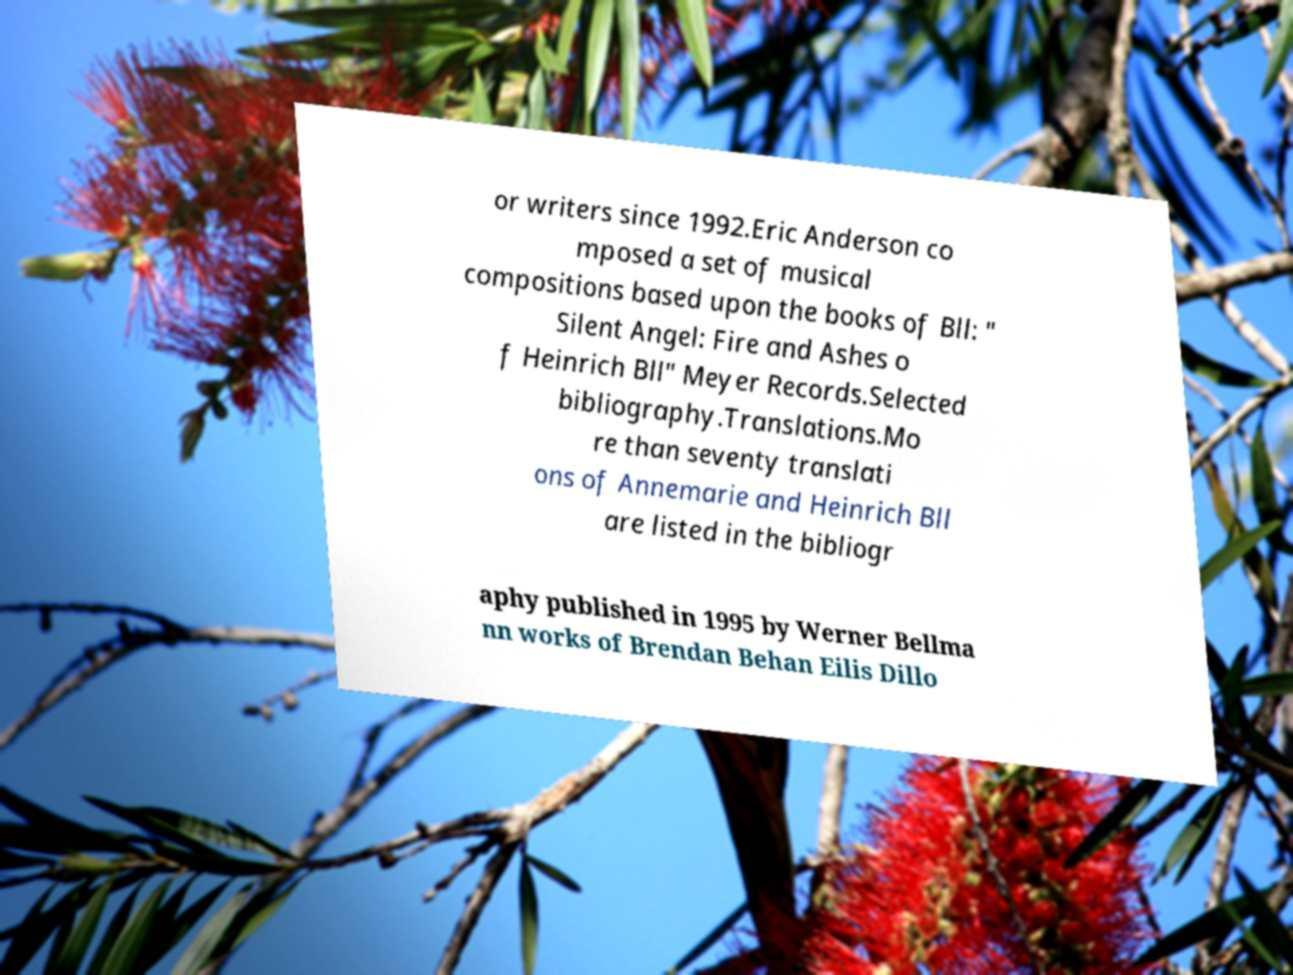What messages or text are displayed in this image? I need them in a readable, typed format. or writers since 1992.Eric Anderson co mposed a set of musical compositions based upon the books of Bll: " Silent Angel: Fire and Ashes o f Heinrich Bll" Meyer Records.Selected bibliography.Translations.Mo re than seventy translati ons of Annemarie and Heinrich Bll are listed in the bibliogr aphy published in 1995 by Werner Bellma nn works of Brendan Behan Eilis Dillo 